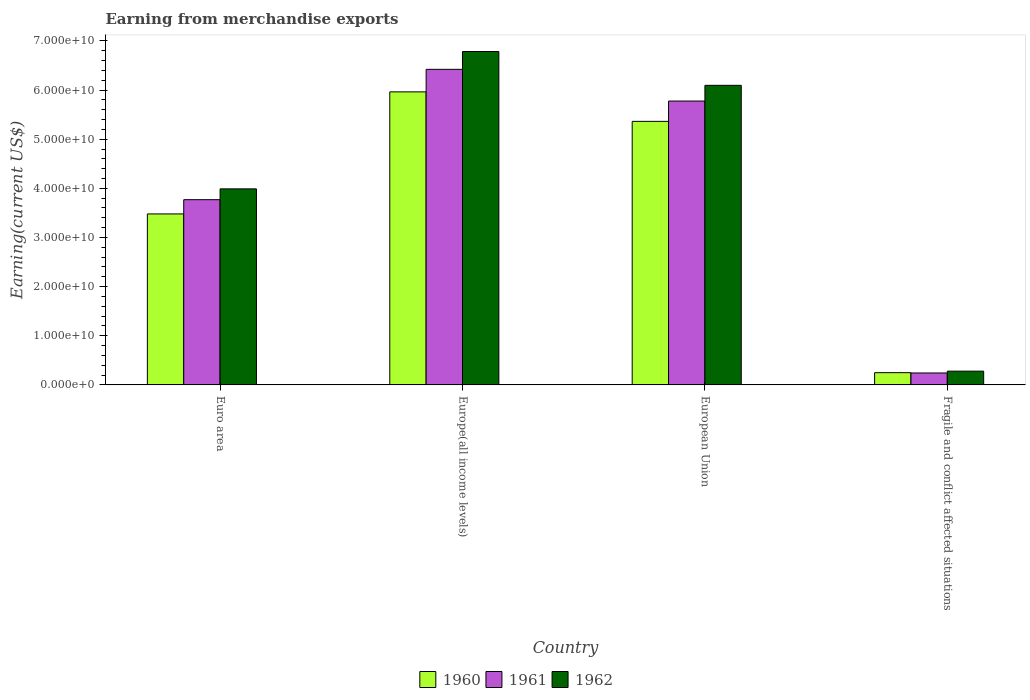How many different coloured bars are there?
Offer a terse response. 3. Are the number of bars on each tick of the X-axis equal?
Offer a very short reply. Yes. How many bars are there on the 4th tick from the left?
Provide a succinct answer. 3. How many bars are there on the 1st tick from the right?
Your response must be concise. 3. What is the label of the 1st group of bars from the left?
Your response must be concise. Euro area. What is the amount earned from merchandise exports in 1961 in Euro area?
Offer a terse response. 3.77e+1. Across all countries, what is the maximum amount earned from merchandise exports in 1962?
Offer a terse response. 6.78e+1. Across all countries, what is the minimum amount earned from merchandise exports in 1960?
Make the answer very short. 2.49e+09. In which country was the amount earned from merchandise exports in 1962 maximum?
Keep it short and to the point. Europe(all income levels). In which country was the amount earned from merchandise exports in 1962 minimum?
Provide a short and direct response. Fragile and conflict affected situations. What is the total amount earned from merchandise exports in 1961 in the graph?
Make the answer very short. 1.62e+11. What is the difference between the amount earned from merchandise exports in 1962 in Euro area and that in Europe(all income levels)?
Give a very brief answer. -2.79e+1. What is the difference between the amount earned from merchandise exports in 1962 in European Union and the amount earned from merchandise exports in 1960 in Europe(all income levels)?
Keep it short and to the point. 1.33e+09. What is the average amount earned from merchandise exports in 1961 per country?
Your response must be concise. 4.05e+1. What is the difference between the amount earned from merchandise exports of/in 1961 and amount earned from merchandise exports of/in 1962 in European Union?
Ensure brevity in your answer.  -3.20e+09. What is the ratio of the amount earned from merchandise exports in 1961 in European Union to that in Fragile and conflict affected situations?
Provide a succinct answer. 23.77. Is the amount earned from merchandise exports in 1960 in Euro area less than that in Fragile and conflict affected situations?
Give a very brief answer. No. What is the difference between the highest and the second highest amount earned from merchandise exports in 1961?
Offer a very short reply. 2.65e+1. What is the difference between the highest and the lowest amount earned from merchandise exports in 1962?
Provide a short and direct response. 6.50e+1. What does the 2nd bar from the right in Europe(all income levels) represents?
Your answer should be compact. 1961. Are all the bars in the graph horizontal?
Keep it short and to the point. No. How many countries are there in the graph?
Provide a succinct answer. 4. Where does the legend appear in the graph?
Your response must be concise. Bottom center. How are the legend labels stacked?
Offer a terse response. Horizontal. What is the title of the graph?
Offer a terse response. Earning from merchandise exports. What is the label or title of the X-axis?
Provide a succinct answer. Country. What is the label or title of the Y-axis?
Provide a succinct answer. Earning(current US$). What is the Earning(current US$) in 1960 in Euro area?
Your answer should be very brief. 3.48e+1. What is the Earning(current US$) of 1961 in Euro area?
Offer a terse response. 3.77e+1. What is the Earning(current US$) of 1962 in Euro area?
Offer a terse response. 3.99e+1. What is the Earning(current US$) of 1960 in Europe(all income levels)?
Ensure brevity in your answer.  5.96e+1. What is the Earning(current US$) in 1961 in Europe(all income levels)?
Keep it short and to the point. 6.42e+1. What is the Earning(current US$) of 1962 in Europe(all income levels)?
Provide a succinct answer. 6.78e+1. What is the Earning(current US$) of 1960 in European Union?
Your answer should be very brief. 5.36e+1. What is the Earning(current US$) of 1961 in European Union?
Keep it short and to the point. 5.78e+1. What is the Earning(current US$) of 1962 in European Union?
Make the answer very short. 6.10e+1. What is the Earning(current US$) in 1960 in Fragile and conflict affected situations?
Make the answer very short. 2.49e+09. What is the Earning(current US$) in 1961 in Fragile and conflict affected situations?
Offer a very short reply. 2.43e+09. What is the Earning(current US$) of 1962 in Fragile and conflict affected situations?
Your response must be concise. 2.80e+09. Across all countries, what is the maximum Earning(current US$) in 1960?
Your response must be concise. 5.96e+1. Across all countries, what is the maximum Earning(current US$) of 1961?
Provide a succinct answer. 6.42e+1. Across all countries, what is the maximum Earning(current US$) of 1962?
Your answer should be very brief. 6.78e+1. Across all countries, what is the minimum Earning(current US$) of 1960?
Offer a terse response. 2.49e+09. Across all countries, what is the minimum Earning(current US$) of 1961?
Provide a succinct answer. 2.43e+09. Across all countries, what is the minimum Earning(current US$) of 1962?
Provide a short and direct response. 2.80e+09. What is the total Earning(current US$) in 1960 in the graph?
Your response must be concise. 1.51e+11. What is the total Earning(current US$) in 1961 in the graph?
Keep it short and to the point. 1.62e+11. What is the total Earning(current US$) of 1962 in the graph?
Your response must be concise. 1.71e+11. What is the difference between the Earning(current US$) of 1960 in Euro area and that in Europe(all income levels)?
Offer a very short reply. -2.48e+1. What is the difference between the Earning(current US$) of 1961 in Euro area and that in Europe(all income levels)?
Make the answer very short. -2.65e+1. What is the difference between the Earning(current US$) of 1962 in Euro area and that in Europe(all income levels)?
Your answer should be compact. -2.79e+1. What is the difference between the Earning(current US$) in 1960 in Euro area and that in European Union?
Provide a succinct answer. -1.88e+1. What is the difference between the Earning(current US$) of 1961 in Euro area and that in European Union?
Keep it short and to the point. -2.01e+1. What is the difference between the Earning(current US$) in 1962 in Euro area and that in European Union?
Make the answer very short. -2.11e+1. What is the difference between the Earning(current US$) of 1960 in Euro area and that in Fragile and conflict affected situations?
Offer a very short reply. 3.23e+1. What is the difference between the Earning(current US$) of 1961 in Euro area and that in Fragile and conflict affected situations?
Your answer should be very brief. 3.53e+1. What is the difference between the Earning(current US$) of 1962 in Euro area and that in Fragile and conflict affected situations?
Your answer should be very brief. 3.71e+1. What is the difference between the Earning(current US$) of 1960 in Europe(all income levels) and that in European Union?
Make the answer very short. 6.00e+09. What is the difference between the Earning(current US$) of 1961 in Europe(all income levels) and that in European Union?
Give a very brief answer. 6.45e+09. What is the difference between the Earning(current US$) in 1962 in Europe(all income levels) and that in European Union?
Make the answer very short. 6.88e+09. What is the difference between the Earning(current US$) of 1960 in Europe(all income levels) and that in Fragile and conflict affected situations?
Ensure brevity in your answer.  5.71e+1. What is the difference between the Earning(current US$) of 1961 in Europe(all income levels) and that in Fragile and conflict affected situations?
Keep it short and to the point. 6.18e+1. What is the difference between the Earning(current US$) of 1962 in Europe(all income levels) and that in Fragile and conflict affected situations?
Give a very brief answer. 6.50e+1. What is the difference between the Earning(current US$) of 1960 in European Union and that in Fragile and conflict affected situations?
Offer a very short reply. 5.11e+1. What is the difference between the Earning(current US$) of 1961 in European Union and that in Fragile and conflict affected situations?
Provide a short and direct response. 5.53e+1. What is the difference between the Earning(current US$) of 1962 in European Union and that in Fragile and conflict affected situations?
Keep it short and to the point. 5.82e+1. What is the difference between the Earning(current US$) in 1960 in Euro area and the Earning(current US$) in 1961 in Europe(all income levels)?
Keep it short and to the point. -2.94e+1. What is the difference between the Earning(current US$) of 1960 in Euro area and the Earning(current US$) of 1962 in Europe(all income levels)?
Give a very brief answer. -3.30e+1. What is the difference between the Earning(current US$) in 1961 in Euro area and the Earning(current US$) in 1962 in Europe(all income levels)?
Provide a short and direct response. -3.01e+1. What is the difference between the Earning(current US$) of 1960 in Euro area and the Earning(current US$) of 1961 in European Union?
Offer a very short reply. -2.30e+1. What is the difference between the Earning(current US$) in 1960 in Euro area and the Earning(current US$) in 1962 in European Union?
Your answer should be very brief. -2.62e+1. What is the difference between the Earning(current US$) in 1961 in Euro area and the Earning(current US$) in 1962 in European Union?
Make the answer very short. -2.33e+1. What is the difference between the Earning(current US$) of 1960 in Euro area and the Earning(current US$) of 1961 in Fragile and conflict affected situations?
Make the answer very short. 3.24e+1. What is the difference between the Earning(current US$) of 1960 in Euro area and the Earning(current US$) of 1962 in Fragile and conflict affected situations?
Make the answer very short. 3.20e+1. What is the difference between the Earning(current US$) in 1961 in Euro area and the Earning(current US$) in 1962 in Fragile and conflict affected situations?
Keep it short and to the point. 3.49e+1. What is the difference between the Earning(current US$) of 1960 in Europe(all income levels) and the Earning(current US$) of 1961 in European Union?
Keep it short and to the point. 1.87e+09. What is the difference between the Earning(current US$) of 1960 in Europe(all income levels) and the Earning(current US$) of 1962 in European Union?
Make the answer very short. -1.33e+09. What is the difference between the Earning(current US$) in 1961 in Europe(all income levels) and the Earning(current US$) in 1962 in European Union?
Offer a very short reply. 3.26e+09. What is the difference between the Earning(current US$) of 1960 in Europe(all income levels) and the Earning(current US$) of 1961 in Fragile and conflict affected situations?
Your answer should be compact. 5.72e+1. What is the difference between the Earning(current US$) in 1960 in Europe(all income levels) and the Earning(current US$) in 1962 in Fragile and conflict affected situations?
Offer a terse response. 5.68e+1. What is the difference between the Earning(current US$) of 1961 in Europe(all income levels) and the Earning(current US$) of 1962 in Fragile and conflict affected situations?
Your answer should be very brief. 6.14e+1. What is the difference between the Earning(current US$) in 1960 in European Union and the Earning(current US$) in 1961 in Fragile and conflict affected situations?
Make the answer very short. 5.12e+1. What is the difference between the Earning(current US$) in 1960 in European Union and the Earning(current US$) in 1962 in Fragile and conflict affected situations?
Your answer should be compact. 5.08e+1. What is the difference between the Earning(current US$) in 1961 in European Union and the Earning(current US$) in 1962 in Fragile and conflict affected situations?
Offer a terse response. 5.50e+1. What is the average Earning(current US$) in 1960 per country?
Ensure brevity in your answer.  3.76e+1. What is the average Earning(current US$) in 1961 per country?
Make the answer very short. 4.05e+1. What is the average Earning(current US$) of 1962 per country?
Ensure brevity in your answer.  4.29e+1. What is the difference between the Earning(current US$) in 1960 and Earning(current US$) in 1961 in Euro area?
Make the answer very short. -2.90e+09. What is the difference between the Earning(current US$) in 1960 and Earning(current US$) in 1962 in Euro area?
Ensure brevity in your answer.  -5.10e+09. What is the difference between the Earning(current US$) of 1961 and Earning(current US$) of 1962 in Euro area?
Give a very brief answer. -2.20e+09. What is the difference between the Earning(current US$) in 1960 and Earning(current US$) in 1961 in Europe(all income levels)?
Give a very brief answer. -4.58e+09. What is the difference between the Earning(current US$) of 1960 and Earning(current US$) of 1962 in Europe(all income levels)?
Give a very brief answer. -8.21e+09. What is the difference between the Earning(current US$) of 1961 and Earning(current US$) of 1962 in Europe(all income levels)?
Offer a very short reply. -3.62e+09. What is the difference between the Earning(current US$) in 1960 and Earning(current US$) in 1961 in European Union?
Keep it short and to the point. -4.13e+09. What is the difference between the Earning(current US$) of 1960 and Earning(current US$) of 1962 in European Union?
Offer a terse response. -7.33e+09. What is the difference between the Earning(current US$) of 1961 and Earning(current US$) of 1962 in European Union?
Offer a very short reply. -3.20e+09. What is the difference between the Earning(current US$) of 1960 and Earning(current US$) of 1961 in Fragile and conflict affected situations?
Give a very brief answer. 6.07e+07. What is the difference between the Earning(current US$) of 1960 and Earning(current US$) of 1962 in Fragile and conflict affected situations?
Offer a very short reply. -3.09e+08. What is the difference between the Earning(current US$) in 1961 and Earning(current US$) in 1962 in Fragile and conflict affected situations?
Your answer should be compact. -3.69e+08. What is the ratio of the Earning(current US$) of 1960 in Euro area to that in Europe(all income levels)?
Your answer should be very brief. 0.58. What is the ratio of the Earning(current US$) in 1961 in Euro area to that in Europe(all income levels)?
Provide a short and direct response. 0.59. What is the ratio of the Earning(current US$) of 1962 in Euro area to that in Europe(all income levels)?
Ensure brevity in your answer.  0.59. What is the ratio of the Earning(current US$) of 1960 in Euro area to that in European Union?
Your answer should be compact. 0.65. What is the ratio of the Earning(current US$) in 1961 in Euro area to that in European Union?
Offer a very short reply. 0.65. What is the ratio of the Earning(current US$) in 1962 in Euro area to that in European Union?
Make the answer very short. 0.65. What is the ratio of the Earning(current US$) of 1960 in Euro area to that in Fragile and conflict affected situations?
Keep it short and to the point. 13.97. What is the ratio of the Earning(current US$) of 1961 in Euro area to that in Fragile and conflict affected situations?
Give a very brief answer. 15.51. What is the ratio of the Earning(current US$) in 1962 in Euro area to that in Fragile and conflict affected situations?
Ensure brevity in your answer.  14.25. What is the ratio of the Earning(current US$) in 1960 in Europe(all income levels) to that in European Union?
Your answer should be compact. 1.11. What is the ratio of the Earning(current US$) in 1961 in Europe(all income levels) to that in European Union?
Make the answer very short. 1.11. What is the ratio of the Earning(current US$) in 1962 in Europe(all income levels) to that in European Union?
Provide a short and direct response. 1.11. What is the ratio of the Earning(current US$) in 1960 in Europe(all income levels) to that in Fragile and conflict affected situations?
Ensure brevity in your answer.  23.94. What is the ratio of the Earning(current US$) in 1961 in Europe(all income levels) to that in Fragile and conflict affected situations?
Your answer should be compact. 26.42. What is the ratio of the Earning(current US$) of 1962 in Europe(all income levels) to that in Fragile and conflict affected situations?
Offer a very short reply. 24.23. What is the ratio of the Earning(current US$) of 1960 in European Union to that in Fragile and conflict affected situations?
Your answer should be very brief. 21.53. What is the ratio of the Earning(current US$) in 1961 in European Union to that in Fragile and conflict affected situations?
Your answer should be very brief. 23.77. What is the ratio of the Earning(current US$) of 1962 in European Union to that in Fragile and conflict affected situations?
Your answer should be very brief. 21.78. What is the difference between the highest and the second highest Earning(current US$) of 1960?
Give a very brief answer. 6.00e+09. What is the difference between the highest and the second highest Earning(current US$) of 1961?
Make the answer very short. 6.45e+09. What is the difference between the highest and the second highest Earning(current US$) of 1962?
Provide a short and direct response. 6.88e+09. What is the difference between the highest and the lowest Earning(current US$) of 1960?
Your answer should be very brief. 5.71e+1. What is the difference between the highest and the lowest Earning(current US$) in 1961?
Ensure brevity in your answer.  6.18e+1. What is the difference between the highest and the lowest Earning(current US$) of 1962?
Your response must be concise. 6.50e+1. 